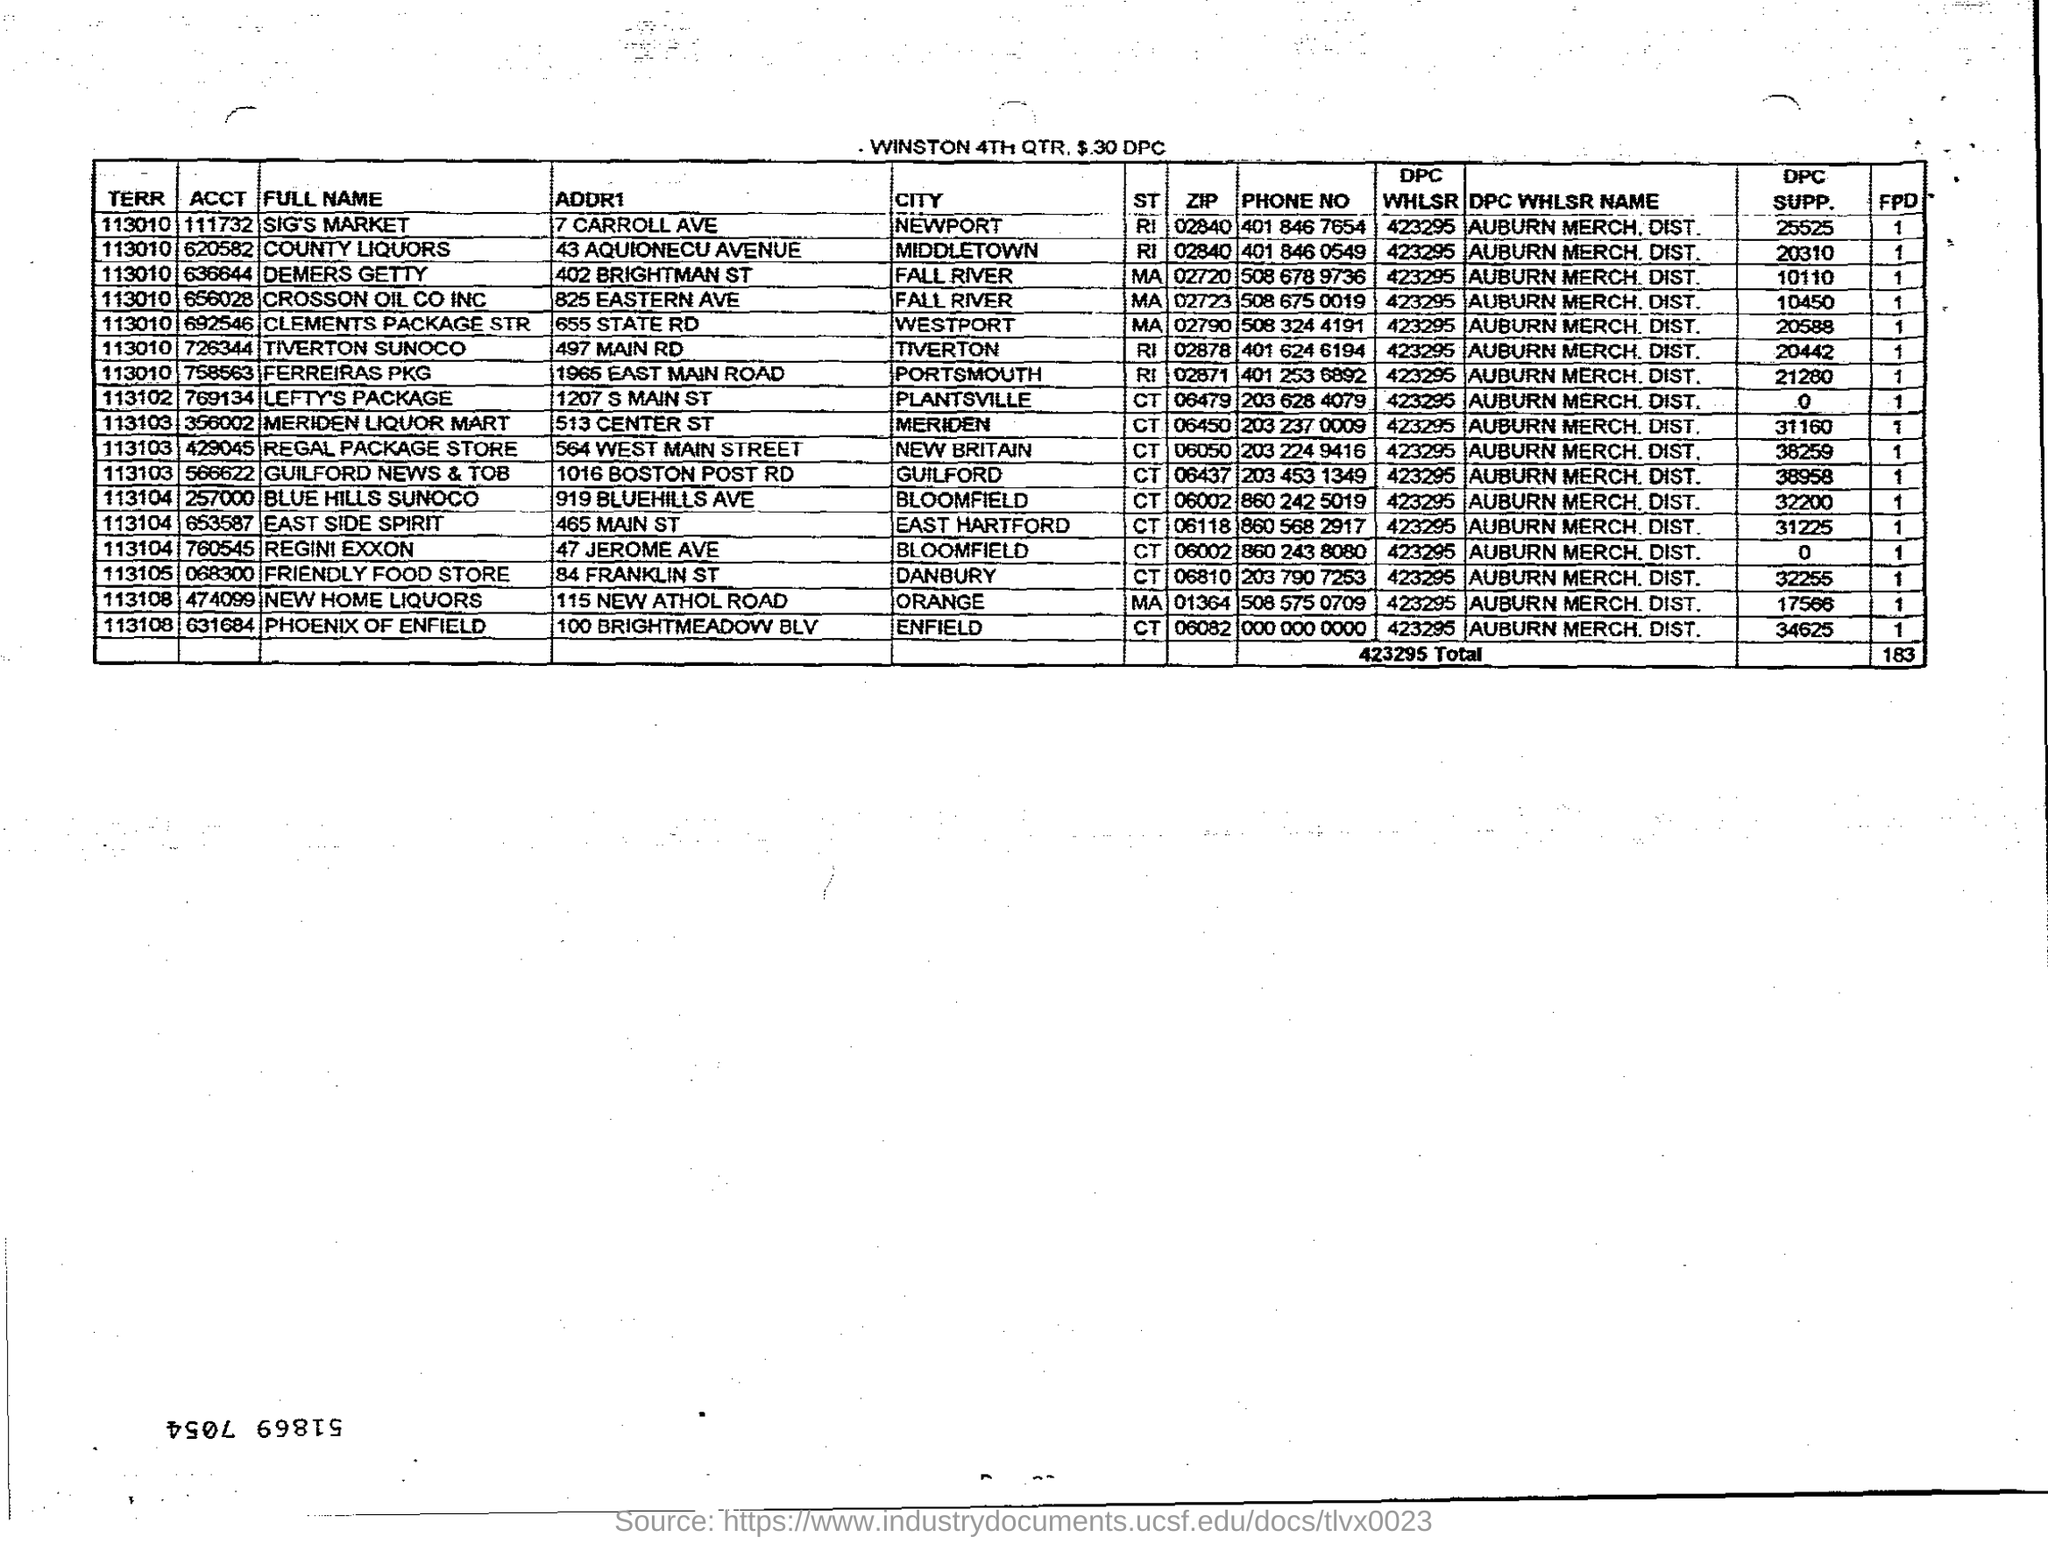Draw attention to some important aspects in this diagram. The DPC SUPP. for Demers Getty is 10110. The City Friendly Food Store is located in Danbury. The ACCT, or Account Control Tower, for County Liquors is 620582. For Regini Exxon located in Bloomfield, the city serves as a crucial component in achieving their business objectives. Lefty's Package is a delivery service located in the city of Plantsville. The purpose of Lefty's Package is to provide efficient and reliable delivery services to the residents of Plantsville and its surrounding areas. 